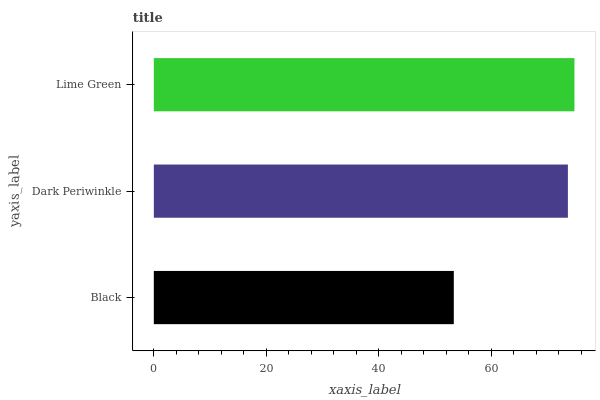Is Black the minimum?
Answer yes or no. Yes. Is Lime Green the maximum?
Answer yes or no. Yes. Is Dark Periwinkle the minimum?
Answer yes or no. No. Is Dark Periwinkle the maximum?
Answer yes or no. No. Is Dark Periwinkle greater than Black?
Answer yes or no. Yes. Is Black less than Dark Periwinkle?
Answer yes or no. Yes. Is Black greater than Dark Periwinkle?
Answer yes or no. No. Is Dark Periwinkle less than Black?
Answer yes or no. No. Is Dark Periwinkle the high median?
Answer yes or no. Yes. Is Dark Periwinkle the low median?
Answer yes or no. Yes. Is Black the high median?
Answer yes or no. No. Is Black the low median?
Answer yes or no. No. 